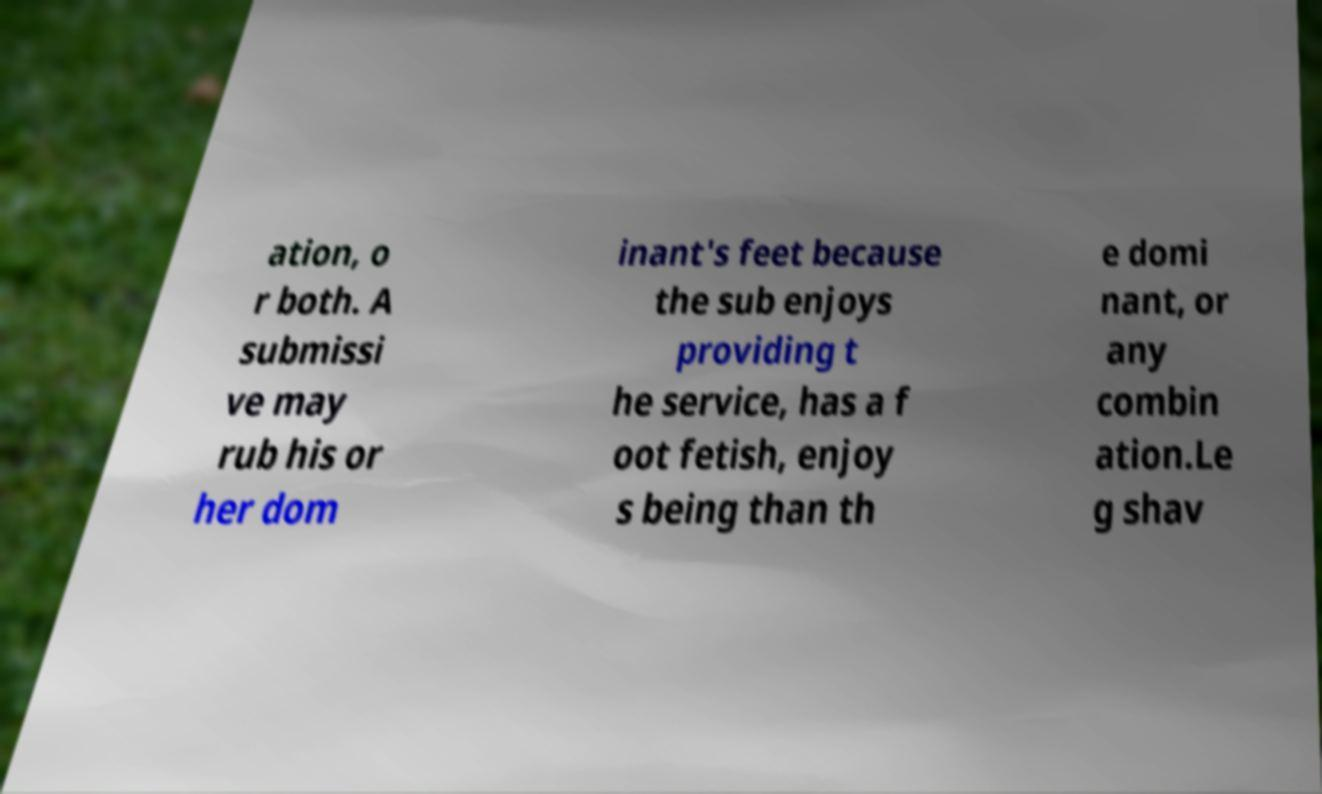What messages or text are displayed in this image? I need them in a readable, typed format. ation, o r both. A submissi ve may rub his or her dom inant's feet because the sub enjoys providing t he service, has a f oot fetish, enjoy s being than th e domi nant, or any combin ation.Le g shav 